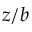<formula> <loc_0><loc_0><loc_500><loc_500>z / b</formula> 